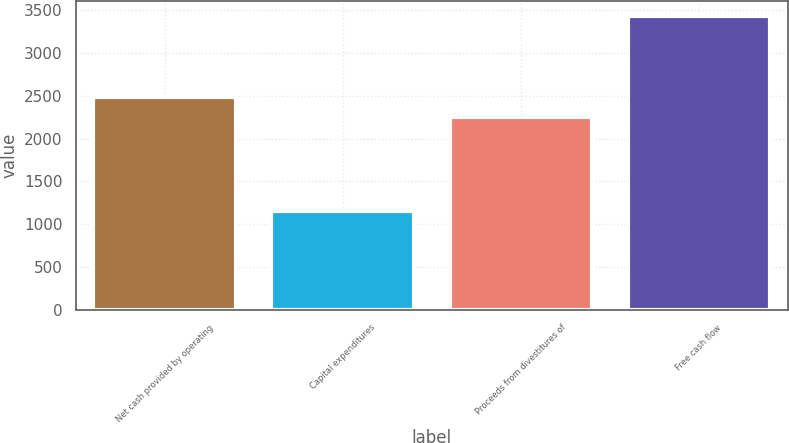Convert chart to OTSL. <chart><loc_0><loc_0><loc_500><loc_500><bar_chart><fcel>Net cash provided by operating<fcel>Capital expenditures<fcel>Proceeds from divestitures of<fcel>Free cash flow<nl><fcel>2481.2<fcel>1151<fcel>2253<fcel>3433<nl></chart> 